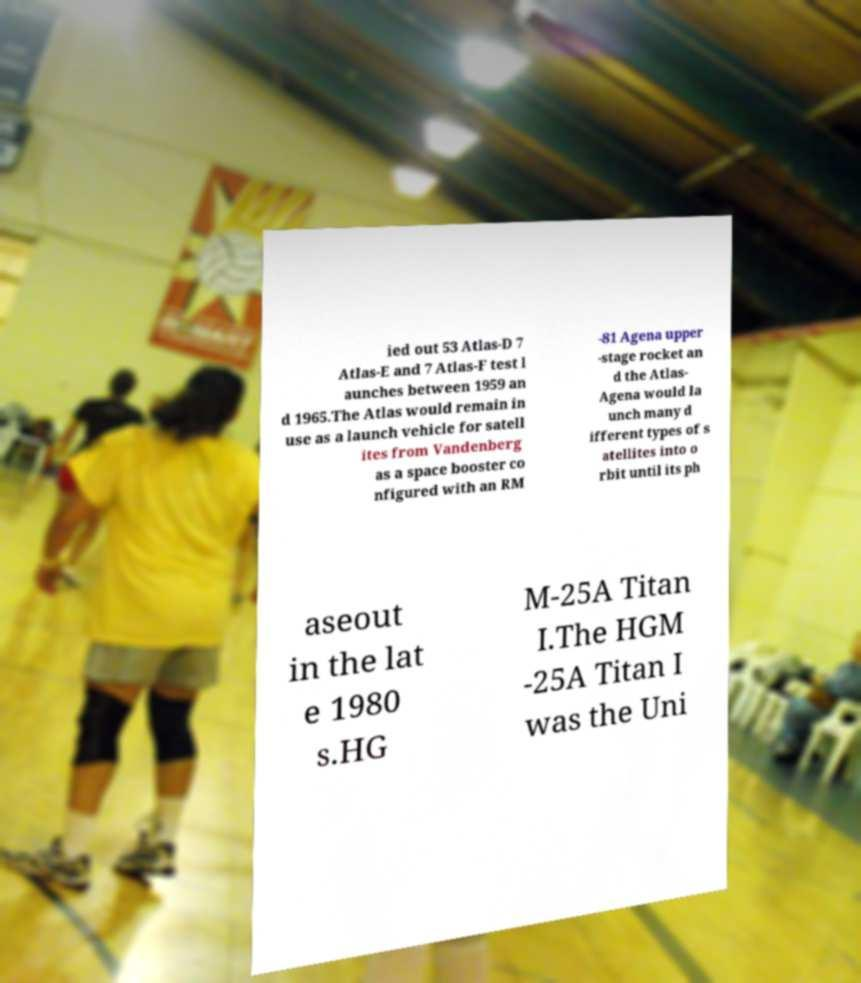There's text embedded in this image that I need extracted. Can you transcribe it verbatim? ied out 53 Atlas-D 7 Atlas-E and 7 Atlas-F test l aunches between 1959 an d 1965.The Atlas would remain in use as a launch vehicle for satell ites from Vandenberg as a space booster co nfigured with an RM -81 Agena upper -stage rocket an d the Atlas- Agena would la unch many d ifferent types of s atellites into o rbit until its ph aseout in the lat e 1980 s.HG M-25A Titan I.The HGM -25A Titan I was the Uni 